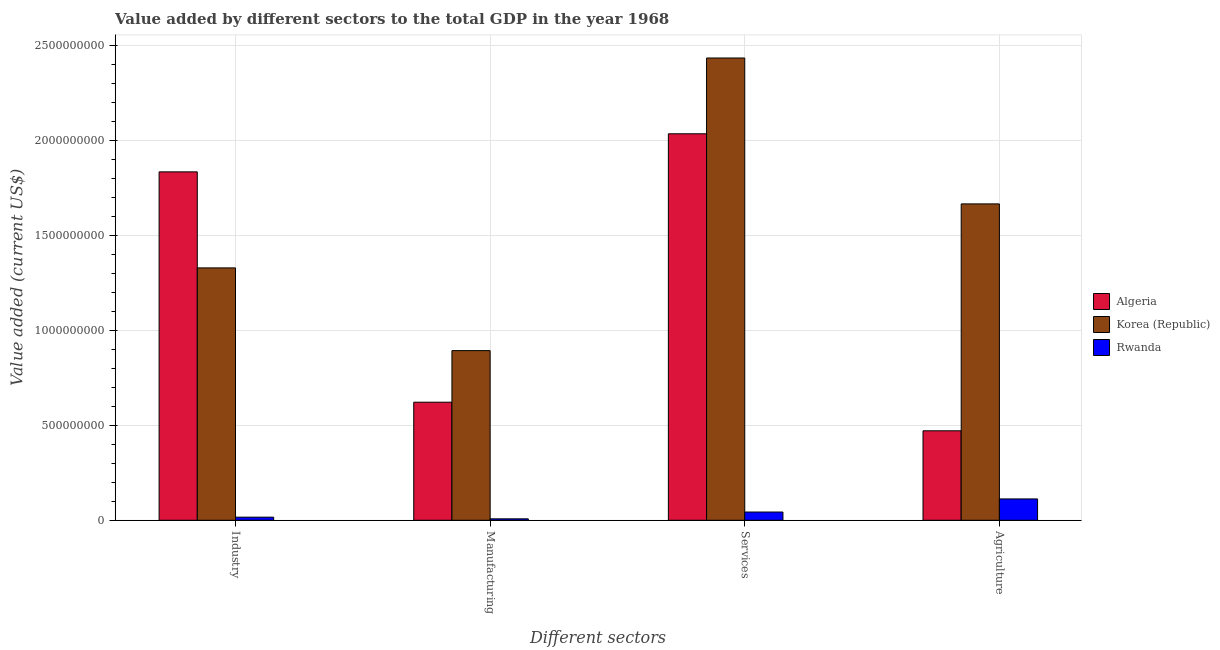How many groups of bars are there?
Keep it short and to the point. 4. Are the number of bars per tick equal to the number of legend labels?
Provide a succinct answer. Yes. Are the number of bars on each tick of the X-axis equal?
Offer a very short reply. Yes. How many bars are there on the 2nd tick from the right?
Your answer should be very brief. 3. What is the label of the 4th group of bars from the left?
Make the answer very short. Agriculture. What is the value added by agricultural sector in Algeria?
Your answer should be compact. 4.71e+08. Across all countries, what is the maximum value added by industrial sector?
Your answer should be compact. 1.84e+09. Across all countries, what is the minimum value added by agricultural sector?
Your answer should be very brief. 1.12e+08. In which country was the value added by agricultural sector maximum?
Offer a very short reply. Korea (Republic). In which country was the value added by agricultural sector minimum?
Keep it short and to the point. Rwanda. What is the total value added by industrial sector in the graph?
Give a very brief answer. 3.18e+09. What is the difference between the value added by agricultural sector in Korea (Republic) and that in Algeria?
Your response must be concise. 1.20e+09. What is the difference between the value added by manufacturing sector in Rwanda and the value added by industrial sector in Korea (Republic)?
Your answer should be very brief. -1.32e+09. What is the average value added by manufacturing sector per country?
Provide a succinct answer. 5.08e+08. What is the difference between the value added by industrial sector and value added by agricultural sector in Korea (Republic)?
Your answer should be compact. -3.37e+08. What is the ratio of the value added by manufacturing sector in Algeria to that in Rwanda?
Make the answer very short. 82.75. Is the value added by manufacturing sector in Rwanda less than that in Korea (Republic)?
Your answer should be very brief. Yes. What is the difference between the highest and the second highest value added by services sector?
Provide a short and direct response. 3.99e+08. What is the difference between the highest and the lowest value added by industrial sector?
Offer a very short reply. 1.82e+09. In how many countries, is the value added by manufacturing sector greater than the average value added by manufacturing sector taken over all countries?
Give a very brief answer. 2. Is the sum of the value added by industrial sector in Rwanda and Korea (Republic) greater than the maximum value added by manufacturing sector across all countries?
Provide a succinct answer. Yes. What does the 1st bar from the left in Services represents?
Offer a very short reply. Algeria. What does the 2nd bar from the right in Agriculture represents?
Your answer should be very brief. Korea (Republic). Is it the case that in every country, the sum of the value added by industrial sector and value added by manufacturing sector is greater than the value added by services sector?
Your answer should be compact. No. Are all the bars in the graph horizontal?
Offer a very short reply. No. How many countries are there in the graph?
Offer a terse response. 3. Does the graph contain grids?
Make the answer very short. Yes. How many legend labels are there?
Your answer should be very brief. 3. What is the title of the graph?
Offer a very short reply. Value added by different sectors to the total GDP in the year 1968. Does "Cyprus" appear as one of the legend labels in the graph?
Keep it short and to the point. No. What is the label or title of the X-axis?
Ensure brevity in your answer.  Different sectors. What is the label or title of the Y-axis?
Provide a short and direct response. Value added (current US$). What is the Value added (current US$) of Algeria in Industry?
Your response must be concise. 1.84e+09. What is the Value added (current US$) in Korea (Republic) in Industry?
Offer a very short reply. 1.33e+09. What is the Value added (current US$) of Rwanda in Industry?
Your answer should be compact. 1.64e+07. What is the Value added (current US$) of Algeria in Manufacturing?
Your answer should be compact. 6.22e+08. What is the Value added (current US$) in Korea (Republic) in Manufacturing?
Give a very brief answer. 8.94e+08. What is the Value added (current US$) of Rwanda in Manufacturing?
Provide a succinct answer. 7.52e+06. What is the Value added (current US$) of Algeria in Services?
Offer a very short reply. 2.04e+09. What is the Value added (current US$) in Korea (Republic) in Services?
Provide a short and direct response. 2.44e+09. What is the Value added (current US$) of Rwanda in Services?
Provide a short and direct response. 4.34e+07. What is the Value added (current US$) in Algeria in Agriculture?
Offer a terse response. 4.71e+08. What is the Value added (current US$) in Korea (Republic) in Agriculture?
Your response must be concise. 1.67e+09. What is the Value added (current US$) of Rwanda in Agriculture?
Your answer should be compact. 1.12e+08. Across all Different sectors, what is the maximum Value added (current US$) of Algeria?
Offer a terse response. 2.04e+09. Across all Different sectors, what is the maximum Value added (current US$) of Korea (Republic)?
Give a very brief answer. 2.44e+09. Across all Different sectors, what is the maximum Value added (current US$) in Rwanda?
Your response must be concise. 1.12e+08. Across all Different sectors, what is the minimum Value added (current US$) of Algeria?
Keep it short and to the point. 4.71e+08. Across all Different sectors, what is the minimum Value added (current US$) in Korea (Republic)?
Offer a terse response. 8.94e+08. Across all Different sectors, what is the minimum Value added (current US$) of Rwanda?
Give a very brief answer. 7.52e+06. What is the total Value added (current US$) in Algeria in the graph?
Offer a very short reply. 4.97e+09. What is the total Value added (current US$) in Korea (Republic) in the graph?
Keep it short and to the point. 6.33e+09. What is the total Value added (current US$) of Rwanda in the graph?
Ensure brevity in your answer.  1.80e+08. What is the difference between the Value added (current US$) in Algeria in Industry and that in Manufacturing?
Keep it short and to the point. 1.21e+09. What is the difference between the Value added (current US$) of Korea (Republic) in Industry and that in Manufacturing?
Give a very brief answer. 4.36e+08. What is the difference between the Value added (current US$) of Rwanda in Industry and that in Manufacturing?
Ensure brevity in your answer.  8.83e+06. What is the difference between the Value added (current US$) of Algeria in Industry and that in Services?
Offer a very short reply. -2.01e+08. What is the difference between the Value added (current US$) of Korea (Republic) in Industry and that in Services?
Make the answer very short. -1.11e+09. What is the difference between the Value added (current US$) of Rwanda in Industry and that in Services?
Your answer should be very brief. -2.71e+07. What is the difference between the Value added (current US$) of Algeria in Industry and that in Agriculture?
Provide a short and direct response. 1.36e+09. What is the difference between the Value added (current US$) of Korea (Republic) in Industry and that in Agriculture?
Your response must be concise. -3.37e+08. What is the difference between the Value added (current US$) in Rwanda in Industry and that in Agriculture?
Ensure brevity in your answer.  -9.61e+07. What is the difference between the Value added (current US$) of Algeria in Manufacturing and that in Services?
Offer a terse response. -1.41e+09. What is the difference between the Value added (current US$) in Korea (Republic) in Manufacturing and that in Services?
Ensure brevity in your answer.  -1.54e+09. What is the difference between the Value added (current US$) of Rwanda in Manufacturing and that in Services?
Your answer should be compact. -3.59e+07. What is the difference between the Value added (current US$) of Algeria in Manufacturing and that in Agriculture?
Keep it short and to the point. 1.51e+08. What is the difference between the Value added (current US$) in Korea (Republic) in Manufacturing and that in Agriculture?
Your answer should be very brief. -7.73e+08. What is the difference between the Value added (current US$) of Rwanda in Manufacturing and that in Agriculture?
Offer a terse response. -1.05e+08. What is the difference between the Value added (current US$) in Algeria in Services and that in Agriculture?
Ensure brevity in your answer.  1.57e+09. What is the difference between the Value added (current US$) in Korea (Republic) in Services and that in Agriculture?
Keep it short and to the point. 7.69e+08. What is the difference between the Value added (current US$) of Rwanda in Services and that in Agriculture?
Provide a short and direct response. -6.90e+07. What is the difference between the Value added (current US$) of Algeria in Industry and the Value added (current US$) of Korea (Republic) in Manufacturing?
Provide a succinct answer. 9.42e+08. What is the difference between the Value added (current US$) in Algeria in Industry and the Value added (current US$) in Rwanda in Manufacturing?
Offer a terse response. 1.83e+09. What is the difference between the Value added (current US$) of Korea (Republic) in Industry and the Value added (current US$) of Rwanda in Manufacturing?
Make the answer very short. 1.32e+09. What is the difference between the Value added (current US$) in Algeria in Industry and the Value added (current US$) in Korea (Republic) in Services?
Make the answer very short. -6.00e+08. What is the difference between the Value added (current US$) of Algeria in Industry and the Value added (current US$) of Rwanda in Services?
Keep it short and to the point. 1.79e+09. What is the difference between the Value added (current US$) of Korea (Republic) in Industry and the Value added (current US$) of Rwanda in Services?
Provide a short and direct response. 1.29e+09. What is the difference between the Value added (current US$) of Algeria in Industry and the Value added (current US$) of Korea (Republic) in Agriculture?
Provide a succinct answer. 1.69e+08. What is the difference between the Value added (current US$) in Algeria in Industry and the Value added (current US$) in Rwanda in Agriculture?
Ensure brevity in your answer.  1.72e+09. What is the difference between the Value added (current US$) in Korea (Republic) in Industry and the Value added (current US$) in Rwanda in Agriculture?
Provide a short and direct response. 1.22e+09. What is the difference between the Value added (current US$) of Algeria in Manufacturing and the Value added (current US$) of Korea (Republic) in Services?
Make the answer very short. -1.81e+09. What is the difference between the Value added (current US$) in Algeria in Manufacturing and the Value added (current US$) in Rwanda in Services?
Give a very brief answer. 5.79e+08. What is the difference between the Value added (current US$) in Korea (Republic) in Manufacturing and the Value added (current US$) in Rwanda in Services?
Ensure brevity in your answer.  8.51e+08. What is the difference between the Value added (current US$) of Algeria in Manufacturing and the Value added (current US$) of Korea (Republic) in Agriculture?
Provide a short and direct response. -1.04e+09. What is the difference between the Value added (current US$) of Algeria in Manufacturing and the Value added (current US$) of Rwanda in Agriculture?
Provide a succinct answer. 5.10e+08. What is the difference between the Value added (current US$) in Korea (Republic) in Manufacturing and the Value added (current US$) in Rwanda in Agriculture?
Ensure brevity in your answer.  7.82e+08. What is the difference between the Value added (current US$) of Algeria in Services and the Value added (current US$) of Korea (Republic) in Agriculture?
Provide a succinct answer. 3.70e+08. What is the difference between the Value added (current US$) in Algeria in Services and the Value added (current US$) in Rwanda in Agriculture?
Offer a very short reply. 1.92e+09. What is the difference between the Value added (current US$) in Korea (Republic) in Services and the Value added (current US$) in Rwanda in Agriculture?
Your response must be concise. 2.32e+09. What is the average Value added (current US$) in Algeria per Different sectors?
Your answer should be very brief. 1.24e+09. What is the average Value added (current US$) of Korea (Republic) per Different sectors?
Keep it short and to the point. 1.58e+09. What is the average Value added (current US$) of Rwanda per Different sectors?
Your answer should be very brief. 4.49e+07. What is the difference between the Value added (current US$) of Algeria and Value added (current US$) of Korea (Republic) in Industry?
Provide a succinct answer. 5.06e+08. What is the difference between the Value added (current US$) in Algeria and Value added (current US$) in Rwanda in Industry?
Your answer should be very brief. 1.82e+09. What is the difference between the Value added (current US$) in Korea (Republic) and Value added (current US$) in Rwanda in Industry?
Provide a short and direct response. 1.31e+09. What is the difference between the Value added (current US$) of Algeria and Value added (current US$) of Korea (Republic) in Manufacturing?
Offer a terse response. -2.72e+08. What is the difference between the Value added (current US$) of Algeria and Value added (current US$) of Rwanda in Manufacturing?
Give a very brief answer. 6.15e+08. What is the difference between the Value added (current US$) of Korea (Republic) and Value added (current US$) of Rwanda in Manufacturing?
Your response must be concise. 8.87e+08. What is the difference between the Value added (current US$) of Algeria and Value added (current US$) of Korea (Republic) in Services?
Make the answer very short. -3.99e+08. What is the difference between the Value added (current US$) in Algeria and Value added (current US$) in Rwanda in Services?
Make the answer very short. 1.99e+09. What is the difference between the Value added (current US$) of Korea (Republic) and Value added (current US$) of Rwanda in Services?
Provide a short and direct response. 2.39e+09. What is the difference between the Value added (current US$) in Algeria and Value added (current US$) in Korea (Republic) in Agriculture?
Ensure brevity in your answer.  -1.20e+09. What is the difference between the Value added (current US$) in Algeria and Value added (current US$) in Rwanda in Agriculture?
Offer a terse response. 3.59e+08. What is the difference between the Value added (current US$) of Korea (Republic) and Value added (current US$) of Rwanda in Agriculture?
Provide a succinct answer. 1.55e+09. What is the ratio of the Value added (current US$) of Algeria in Industry to that in Manufacturing?
Ensure brevity in your answer.  2.95. What is the ratio of the Value added (current US$) in Korea (Republic) in Industry to that in Manufacturing?
Your response must be concise. 1.49. What is the ratio of the Value added (current US$) in Rwanda in Industry to that in Manufacturing?
Your answer should be compact. 2.17. What is the ratio of the Value added (current US$) in Algeria in Industry to that in Services?
Your response must be concise. 0.9. What is the ratio of the Value added (current US$) of Korea (Republic) in Industry to that in Services?
Offer a terse response. 0.55. What is the ratio of the Value added (current US$) of Rwanda in Industry to that in Services?
Offer a very short reply. 0.38. What is the ratio of the Value added (current US$) of Algeria in Industry to that in Agriculture?
Offer a terse response. 3.89. What is the ratio of the Value added (current US$) in Korea (Republic) in Industry to that in Agriculture?
Provide a short and direct response. 0.8. What is the ratio of the Value added (current US$) of Rwanda in Industry to that in Agriculture?
Your answer should be very brief. 0.15. What is the ratio of the Value added (current US$) in Algeria in Manufacturing to that in Services?
Ensure brevity in your answer.  0.31. What is the ratio of the Value added (current US$) in Korea (Republic) in Manufacturing to that in Services?
Give a very brief answer. 0.37. What is the ratio of the Value added (current US$) in Rwanda in Manufacturing to that in Services?
Ensure brevity in your answer.  0.17. What is the ratio of the Value added (current US$) in Algeria in Manufacturing to that in Agriculture?
Provide a succinct answer. 1.32. What is the ratio of the Value added (current US$) of Korea (Republic) in Manufacturing to that in Agriculture?
Make the answer very short. 0.54. What is the ratio of the Value added (current US$) of Rwanda in Manufacturing to that in Agriculture?
Offer a terse response. 0.07. What is the ratio of the Value added (current US$) of Algeria in Services to that in Agriculture?
Provide a short and direct response. 4.32. What is the ratio of the Value added (current US$) in Korea (Republic) in Services to that in Agriculture?
Keep it short and to the point. 1.46. What is the ratio of the Value added (current US$) of Rwanda in Services to that in Agriculture?
Your answer should be very brief. 0.39. What is the difference between the highest and the second highest Value added (current US$) in Algeria?
Give a very brief answer. 2.01e+08. What is the difference between the highest and the second highest Value added (current US$) in Korea (Republic)?
Keep it short and to the point. 7.69e+08. What is the difference between the highest and the second highest Value added (current US$) in Rwanda?
Your response must be concise. 6.90e+07. What is the difference between the highest and the lowest Value added (current US$) in Algeria?
Make the answer very short. 1.57e+09. What is the difference between the highest and the lowest Value added (current US$) in Korea (Republic)?
Keep it short and to the point. 1.54e+09. What is the difference between the highest and the lowest Value added (current US$) of Rwanda?
Ensure brevity in your answer.  1.05e+08. 